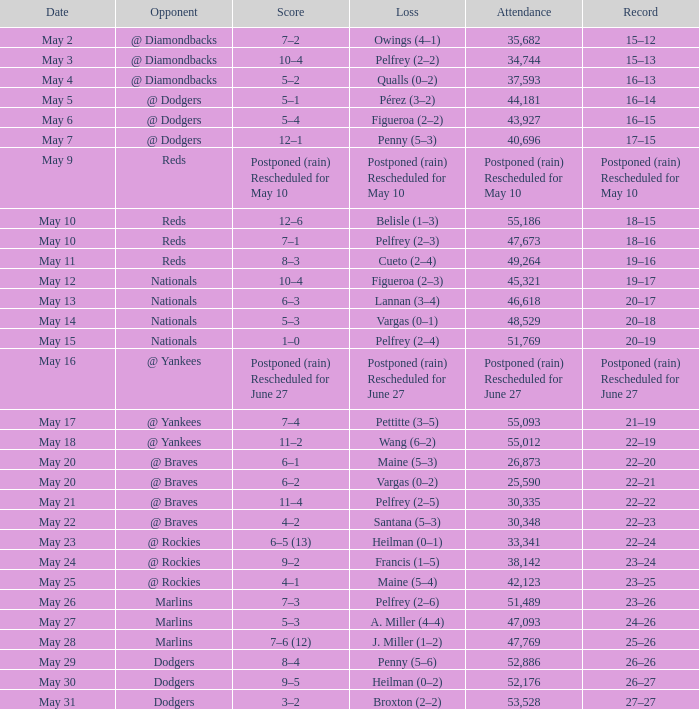Opponent of @ braves, and a Loss of pelfrey (2–5) had what score? 11–4. 